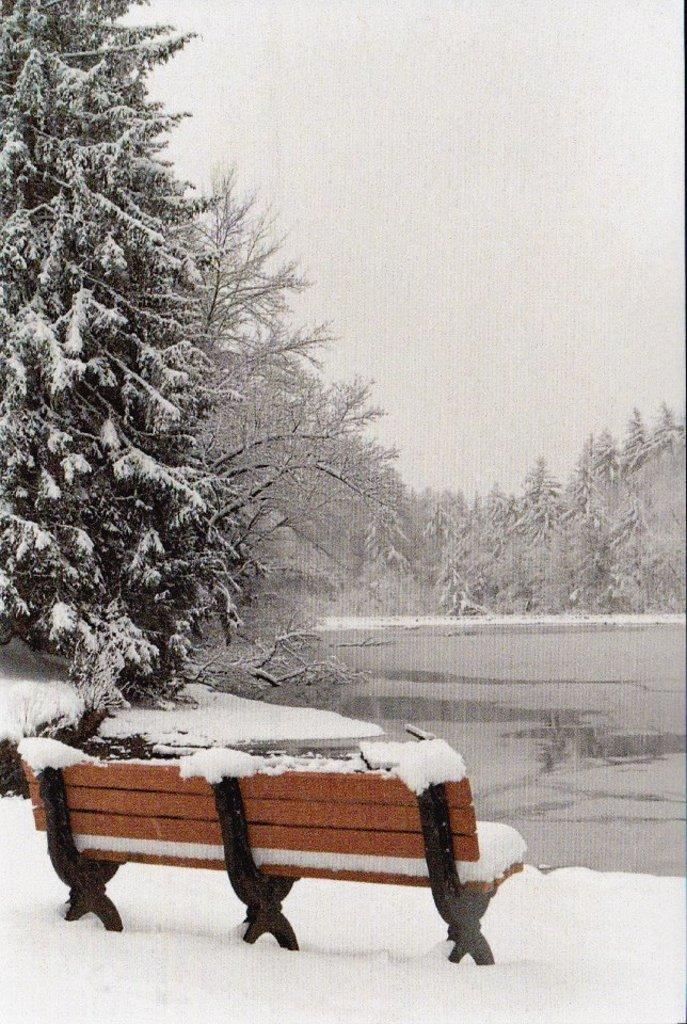What is the main object in the image? There is a bench in the image. Where is the bench located? The bench is placed in snow. What can be seen in the background of the image? There is water, a group of trees, and the sky visible in the background of the image. What type of rod is being used to recite a verse in the image? There is no rod or verse present in the image; it features a bench in the snow with a background of water, trees, and the sky. 